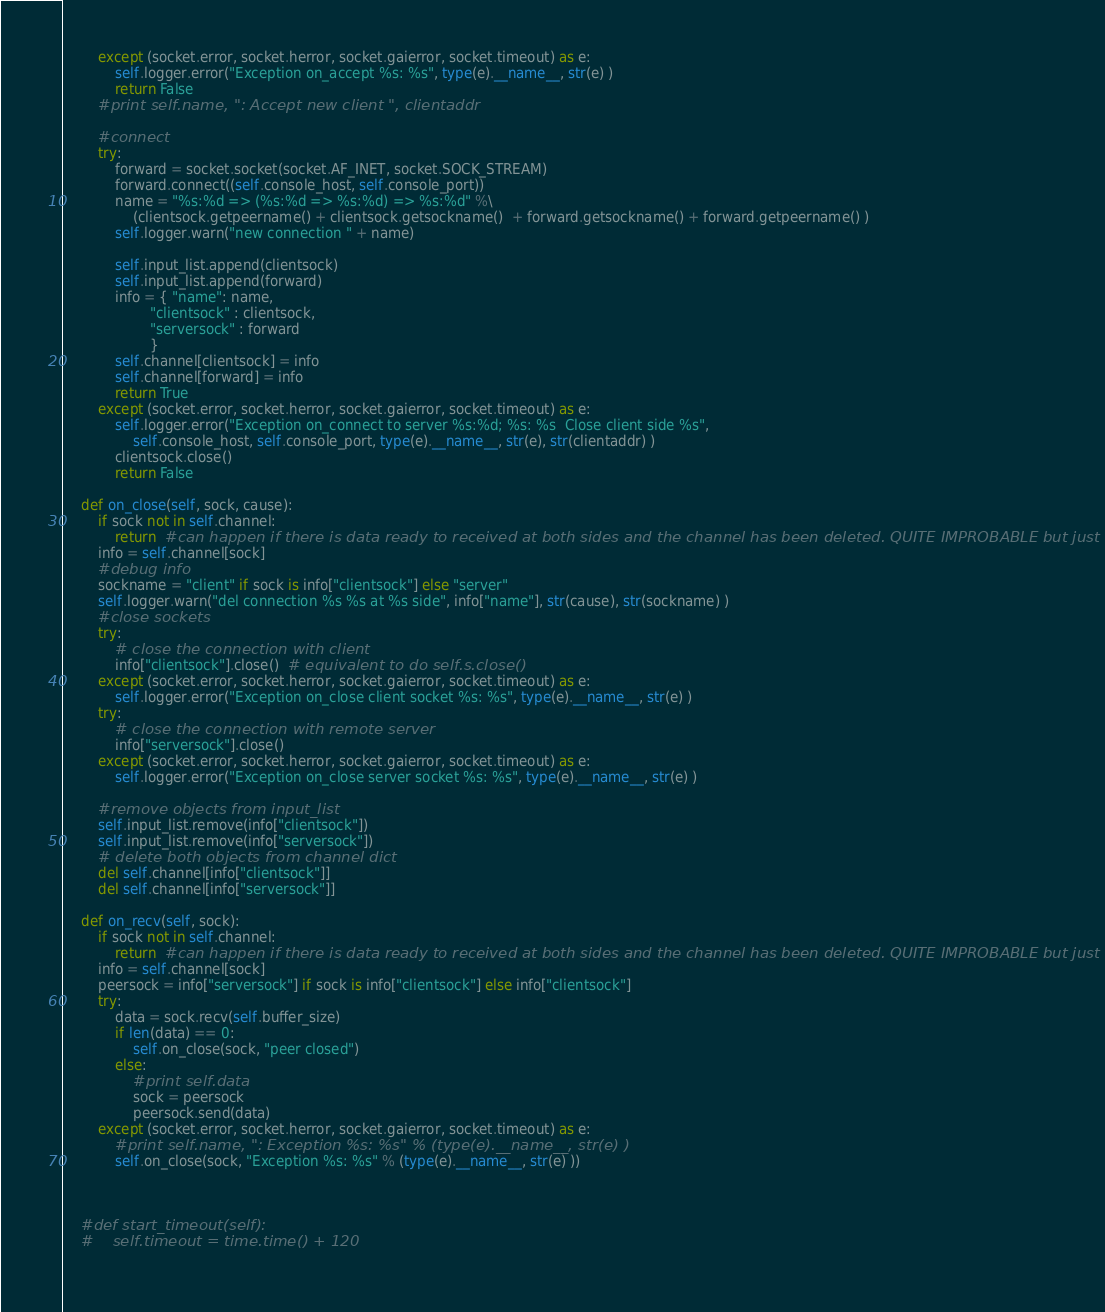<code> <loc_0><loc_0><loc_500><loc_500><_Python_>        except (socket.error, socket.herror, socket.gaierror, socket.timeout) as e:
            self.logger.error("Exception on_accept %s: %s", type(e).__name__, str(e) )
            return False
        #print self.name, ": Accept new client ", clientaddr

        #connect
        try:
            forward = socket.socket(socket.AF_INET, socket.SOCK_STREAM)
            forward.connect((self.console_host, self.console_port))
            name = "%s:%d => (%s:%d => %s:%d) => %s:%d" %\
                (clientsock.getpeername() + clientsock.getsockname()  + forward.getsockname() + forward.getpeername() )
            self.logger.warn("new connection " + name)
                
            self.input_list.append(clientsock)
            self.input_list.append(forward)
            info = { "name": name,
                    "clientsock" : clientsock,
                    "serversock" : forward
                    }
            self.channel[clientsock] = info
            self.channel[forward] = info
            return True
        except (socket.error, socket.herror, socket.gaierror, socket.timeout) as e:
            self.logger.error("Exception on_connect to server %s:%d; %s: %s  Close client side %s",
                self.console_host, self.console_port, type(e).__name__, str(e), str(clientaddr) )
            clientsock.close()
            return False

    def on_close(self, sock, cause):
        if sock not in self.channel:
            return  #can happen if there is data ready to received at both sides and the channel has been deleted. QUITE IMPROBABLE but just in case
        info = self.channel[sock]
        #debug info
        sockname = "client" if sock is info["clientsock"] else "server"
        self.logger.warn("del connection %s %s at %s side", info["name"], str(cause), str(sockname) )
        #close sockets
        try:
            # close the connection with client
            info["clientsock"].close()  # equivalent to do self.s.close()
        except (socket.error, socket.herror, socket.gaierror, socket.timeout) as e:
            self.logger.error("Exception on_close client socket %s: %s", type(e).__name__, str(e) )
        try:
            # close the connection with remote server
            info["serversock"].close()
        except (socket.error, socket.herror, socket.gaierror, socket.timeout) as e:
            self.logger.error("Exception on_close server socket %s: %s", type(e).__name__, str(e) )
        
        #remove objects from input_list
        self.input_list.remove(info["clientsock"])
        self.input_list.remove(info["serversock"])
        # delete both objects from channel dict
        del self.channel[info["clientsock"]]
        del self.channel[info["serversock"]]

    def on_recv(self, sock):
        if sock not in self.channel:
            return  #can happen if there is data ready to received at both sides and the channel has been deleted. QUITE IMPROBABLE but just in case
        info = self.channel[sock]
        peersock = info["serversock"] if sock is info["clientsock"] else info["clientsock"]
        try:
            data = sock.recv(self.buffer_size)
            if len(data) == 0:
                self.on_close(sock, "peer closed")
            else:
                #print self.data
                sock = peersock
                peersock.send(data)
        except (socket.error, socket.herror, socket.gaierror, socket.timeout) as e:
            #print self.name, ": Exception %s: %s" % (type(e).__name__, str(e) )
            self.on_close(sock, "Exception %s: %s" % (type(e).__name__, str(e) ))

        

    #def start_timeout(self):
    #    self.timeout = time.time() + 120
        
</code> 